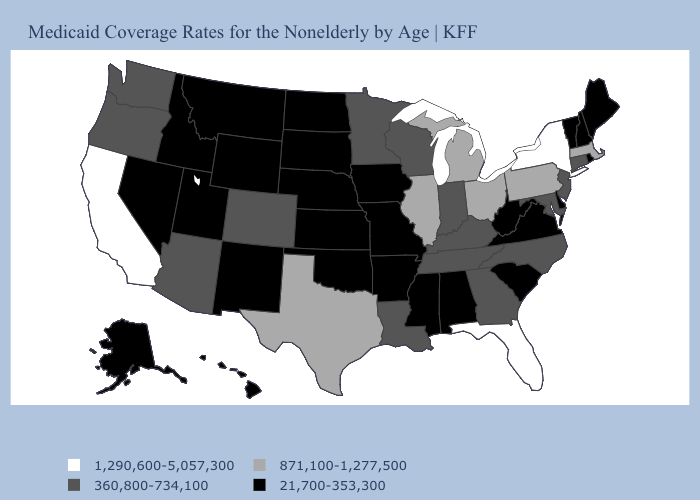What is the value of Nebraska?
Concise answer only. 21,700-353,300. Among the states that border Louisiana , does Texas have the lowest value?
Be succinct. No. Which states have the lowest value in the South?
Be succinct. Alabama, Arkansas, Delaware, Mississippi, Oklahoma, South Carolina, Virginia, West Virginia. What is the value of Virginia?
Concise answer only. 21,700-353,300. Does Pennsylvania have the highest value in the Northeast?
Give a very brief answer. No. Does Kansas have the lowest value in the MidWest?
Keep it brief. Yes. Does Ohio have the lowest value in the MidWest?
Write a very short answer. No. Name the states that have a value in the range 360,800-734,100?
Be succinct. Arizona, Colorado, Connecticut, Georgia, Indiana, Kentucky, Louisiana, Maryland, Minnesota, New Jersey, North Carolina, Oregon, Tennessee, Washington, Wisconsin. Does the first symbol in the legend represent the smallest category?
Write a very short answer. No. Does Indiana have the lowest value in the USA?
Give a very brief answer. No. Among the states that border Pennsylvania , which have the lowest value?
Keep it brief. Delaware, West Virginia. Name the states that have a value in the range 21,700-353,300?
Keep it brief. Alabama, Alaska, Arkansas, Delaware, Hawaii, Idaho, Iowa, Kansas, Maine, Mississippi, Missouri, Montana, Nebraska, Nevada, New Hampshire, New Mexico, North Dakota, Oklahoma, Rhode Island, South Carolina, South Dakota, Utah, Vermont, Virginia, West Virginia, Wyoming. Does Ohio have the lowest value in the MidWest?
Give a very brief answer. No. Among the states that border Rhode Island , does Connecticut have the highest value?
Write a very short answer. No. How many symbols are there in the legend?
Be succinct. 4. 